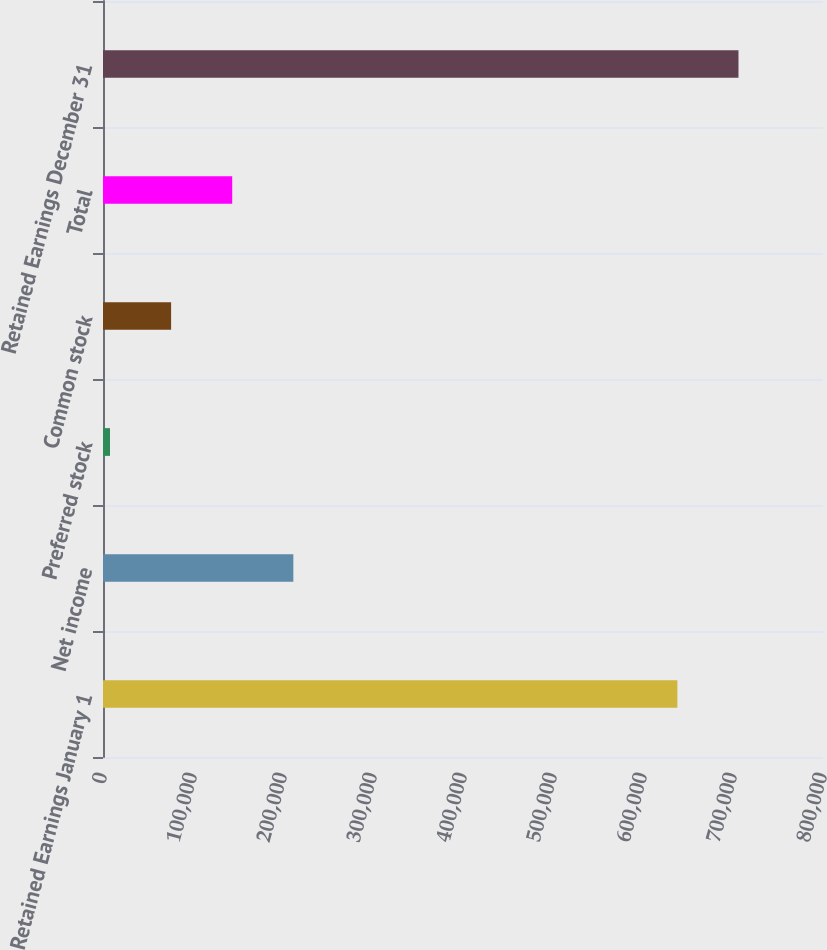Convert chart to OTSL. <chart><loc_0><loc_0><loc_500><loc_500><bar_chart><fcel>Retained Earnings January 1<fcel>Net income<fcel>Preferred stock<fcel>Common stock<fcel>Total<fcel>Retained Earnings December 31<nl><fcel>638193<fcel>211491<fcel>7776<fcel>75681<fcel>143586<fcel>706098<nl></chart> 